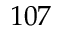<formula> <loc_0><loc_0><loc_500><loc_500>1 0 7</formula> 